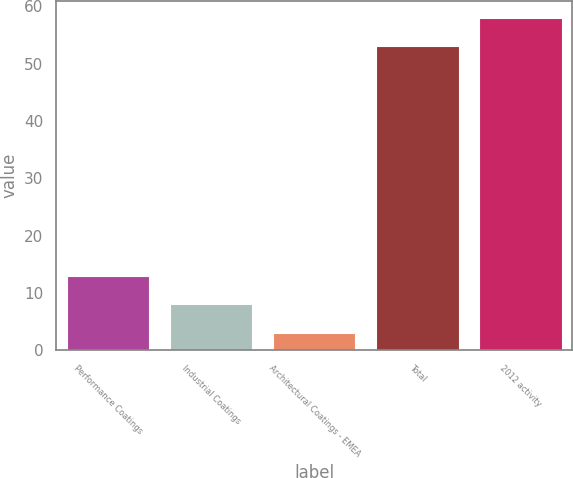<chart> <loc_0><loc_0><loc_500><loc_500><bar_chart><fcel>Performance Coatings<fcel>Industrial Coatings<fcel>Architectural Coatings - EMEA<fcel>Total<fcel>2012 activity<nl><fcel>13<fcel>8<fcel>3<fcel>53<fcel>58<nl></chart> 